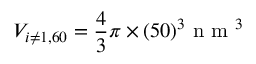Convert formula to latex. <formula><loc_0><loc_0><loc_500><loc_500>V _ { i \neq 1 , 6 0 } = \frac { 4 } { 3 } \pi \times ( 5 0 ) ^ { 3 } n m ^ { 3 }</formula> 